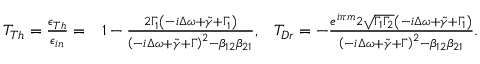<formula> <loc_0><loc_0><loc_500><loc_500>\begin{array} { r l r } { T _ { T h } = \frac { \epsilon _ { T h } } { \epsilon _ { i n } } = } & 1 - \frac { 2 \Gamma _ { 1 } \left ( - i \Delta \omega + \tilde { \gamma } + \Gamma _ { 1 } \right ) } { \left ( - i \Delta \omega + \tilde { \gamma } + \Gamma \right ) ^ { 2 } - \beta _ { 1 2 } \beta _ { 2 1 } } , } & { T _ { D r } = - \frac { e ^ { i \pi m } 2 \sqrt { \Gamma _ { 1 } \Gamma _ { 2 } } \left ( - i \Delta \omega + \tilde { \gamma } + \Gamma _ { 1 } \right ) } { \left ( - i \Delta \omega + \tilde { \gamma } + \Gamma \right ) ^ { 2 } - \beta _ { 1 2 } \beta _ { 2 1 } } . } \end{array}</formula> 